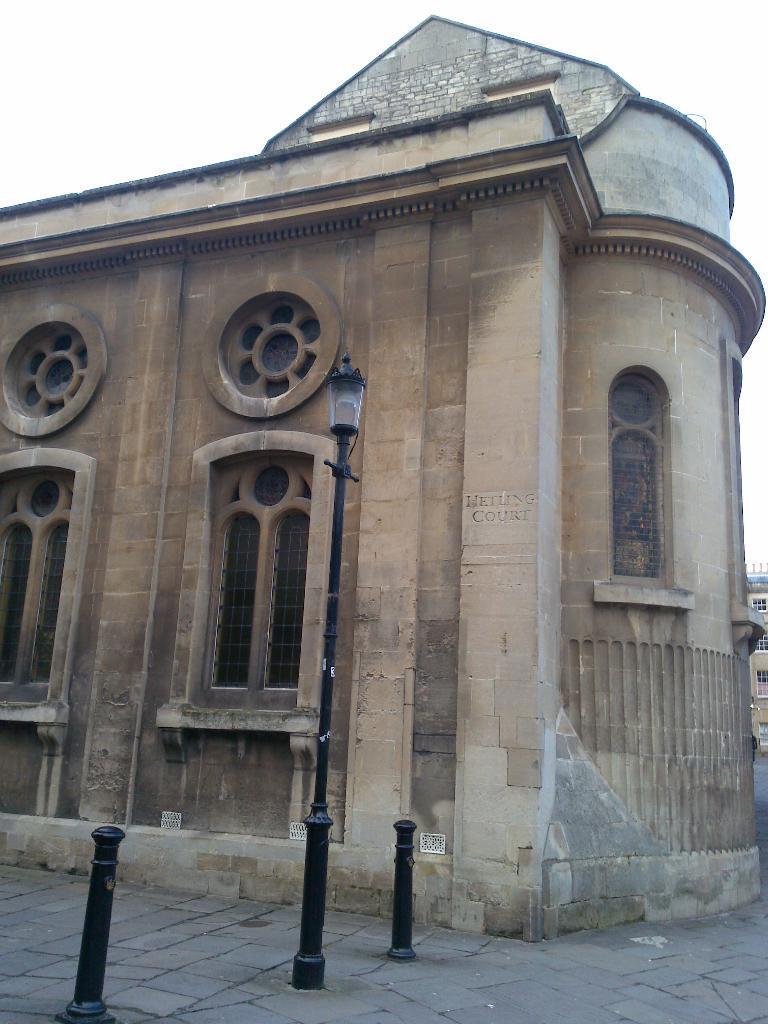Describe this image in one or two sentences. In the picture we can see a historical building with a window which are designed and near to it, we can see a path and in the background we can see a sky. 